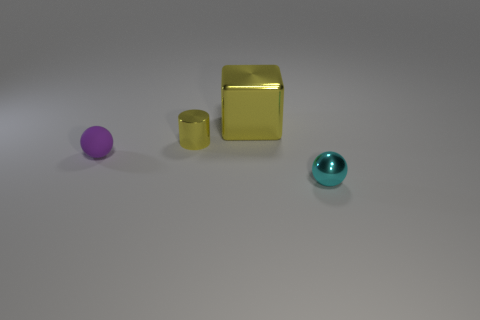Add 4 large green cylinders. How many objects exist? 8 Subtract all purple balls. How many balls are left? 1 Subtract 2 balls. How many balls are left? 0 Subtract all blue cylinders. How many cyan balls are left? 1 Add 4 cyan metallic balls. How many cyan metallic balls are left? 5 Add 4 cyan objects. How many cyan objects exist? 5 Subtract 0 brown spheres. How many objects are left? 4 Subtract all brown cylinders. Subtract all cyan spheres. How many cylinders are left? 1 Subtract all large blue metallic objects. Subtract all cyan things. How many objects are left? 3 